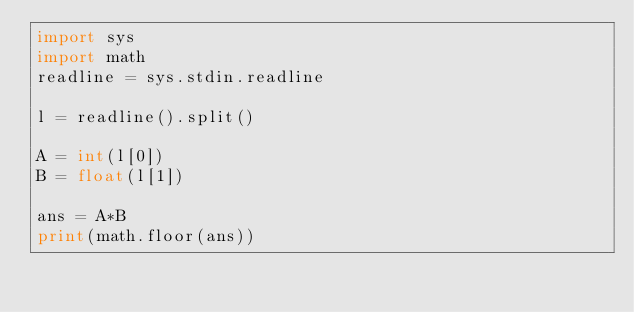<code> <loc_0><loc_0><loc_500><loc_500><_Python_>import sys
import math
readline = sys.stdin.readline
 
l = readline().split()
 
A = int(l[0])
B = float(l[1])
 
ans = A*B
print(math.floor(ans))
</code> 